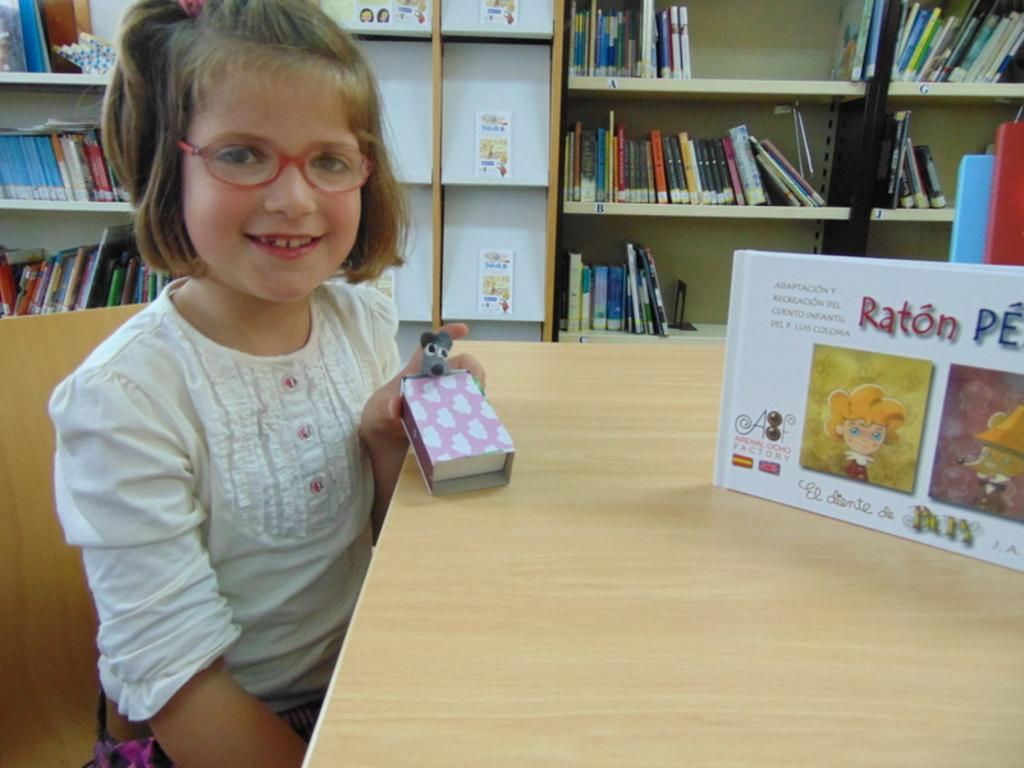<image>
Provide a brief description of the given image. A young girl holds a Raton PE as she sits next to the box. 